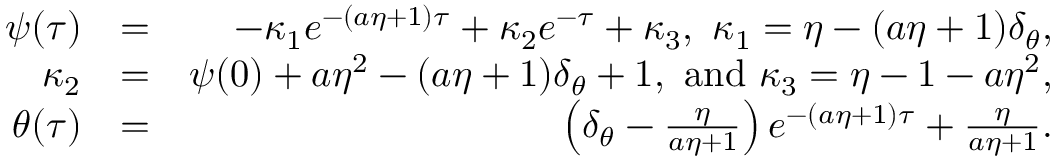Convert formula to latex. <formula><loc_0><loc_0><loc_500><loc_500>\begin{array} { r l r } { \psi ( \tau ) } & { = } & { - \kappa _ { 1 } e ^ { - ( a \eta + 1 ) \tau } + \kappa _ { 2 } e ^ { - \tau } + \kappa _ { 3 } , \ \kappa _ { 1 } = \eta - ( a \eta + 1 ) \delta _ { \theta } , } \\ { \kappa _ { 2 } } & { = } & { \psi ( { 0 } ) + a \eta ^ { 2 } - ( a \eta + 1 ) \delta _ { \theta } + 1 , a n d \kappa _ { 3 } = \eta - 1 - a \eta ^ { 2 } , } \\ { \theta ( \tau ) } & { = } & { \left ( \delta _ { \theta } - \frac { \eta } { a \eta + 1 } \right ) e ^ { - ( a \eta + 1 ) \tau } + \frac { \eta } { a \eta + 1 } . } \end{array}</formula> 